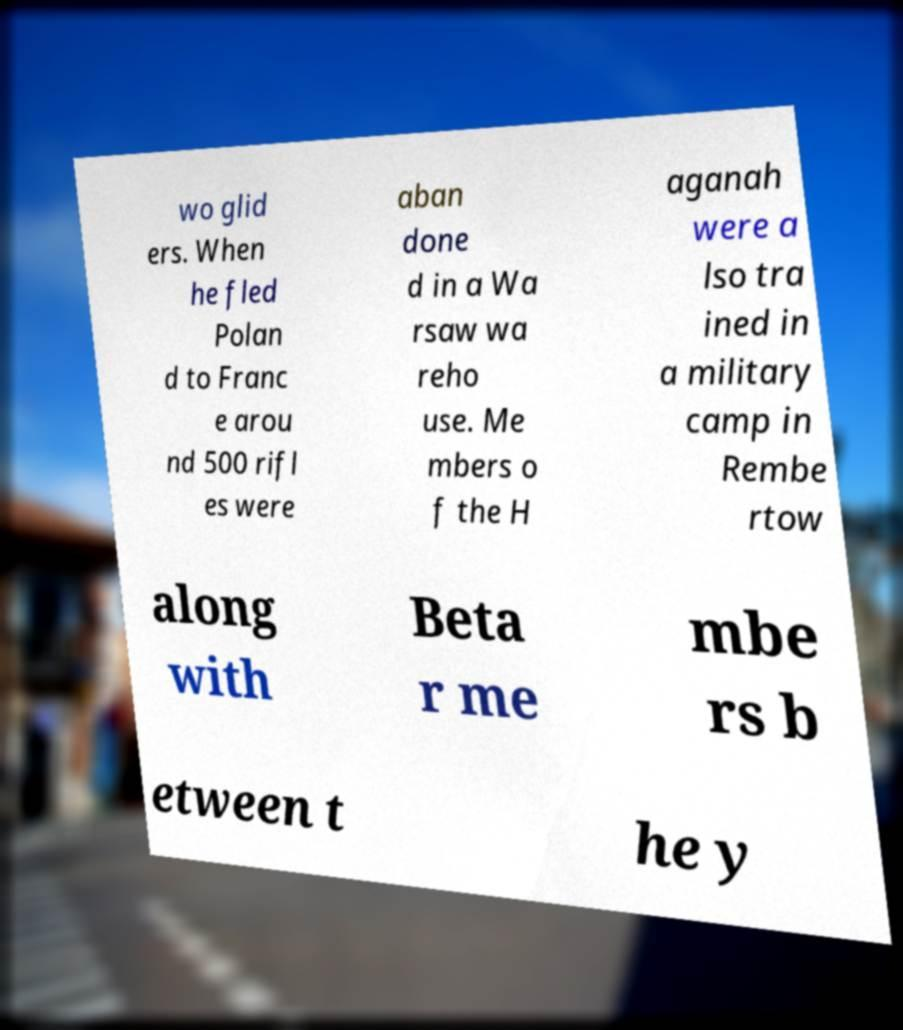Please read and relay the text visible in this image. What does it say? wo glid ers. When he fled Polan d to Franc e arou nd 500 rifl es were aban done d in a Wa rsaw wa reho use. Me mbers o f the H aganah were a lso tra ined in a military camp in Rembe rtow along with Beta r me mbe rs b etween t he y 